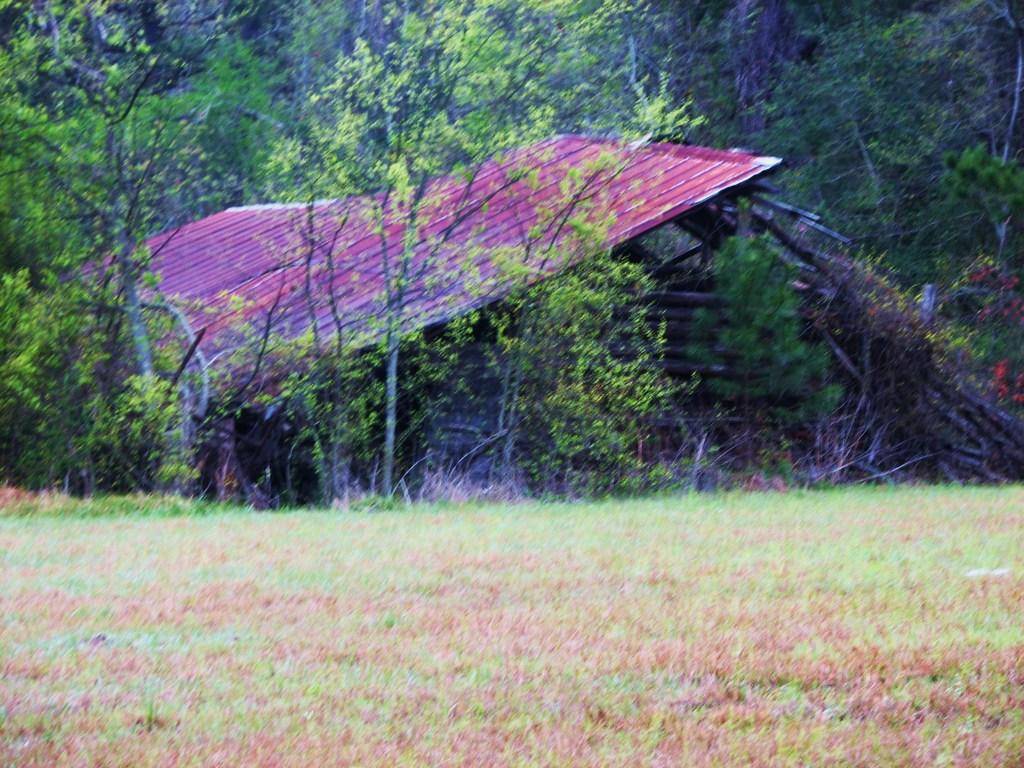What is the main object in the middle of the image? There is a roofing sheet in the middle of the image. What other objects are present in the middle of the image? There are wooden objects in the middle of the image. How is the land in the front of the image described? The land in the front of the image is covered with grass. What can be seen in the background of the image? There are trees in the background of the image. What grade of dirt is visible on the roofing sheet in the image? There is no dirt visible on the roofing sheet in the image. Is there a hill in the background of the image? There is no hill present in the image; only trees are visible in the background. 